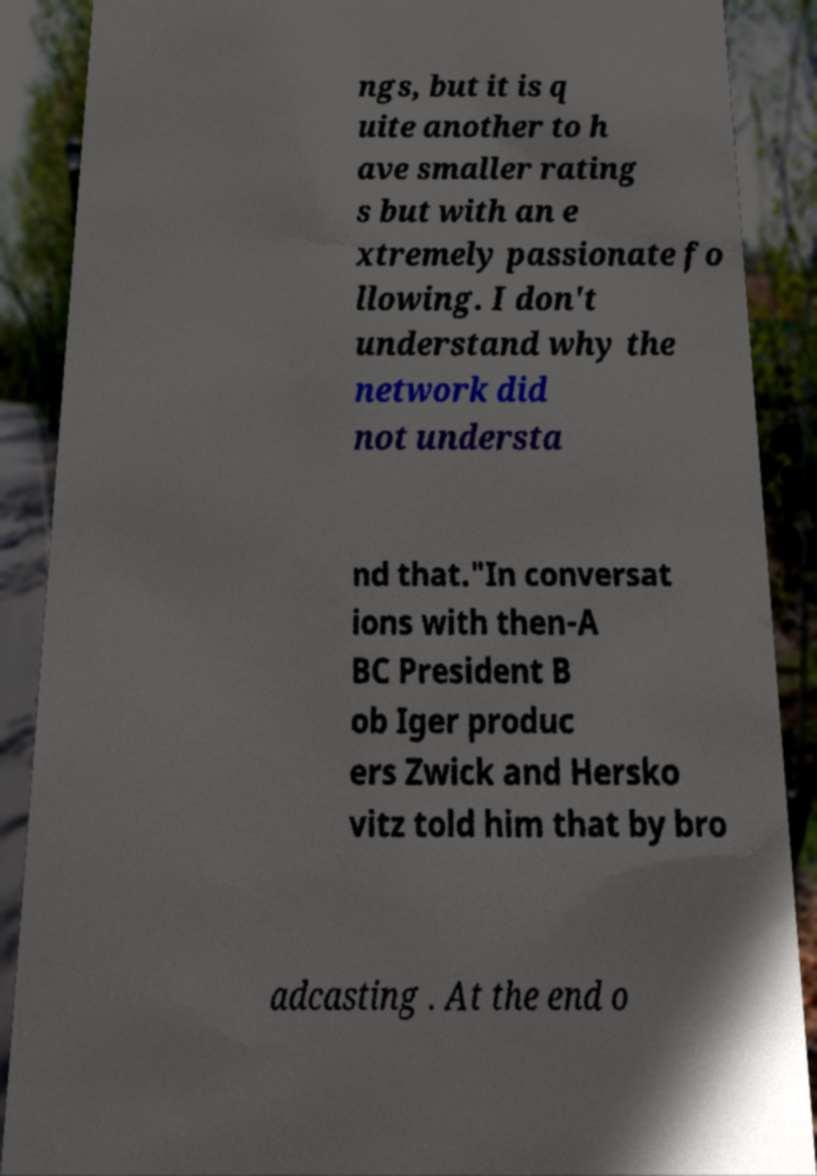For documentation purposes, I need the text within this image transcribed. Could you provide that? ngs, but it is q uite another to h ave smaller rating s but with an e xtremely passionate fo llowing. I don't understand why the network did not understa nd that."In conversat ions with then-A BC President B ob Iger produc ers Zwick and Hersko vitz told him that by bro adcasting . At the end o 